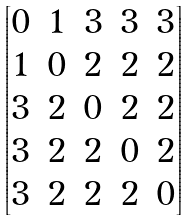<formula> <loc_0><loc_0><loc_500><loc_500>\begin{bmatrix} 0 & 1 & 3 & 3 & 3 \\ 1 & 0 & 2 & 2 & 2 \\ 3 & 2 & 0 & 2 & 2 \\ 3 & 2 & 2 & 0 & 2 \\ 3 & 2 & 2 & 2 & 0 \\ \end{bmatrix}</formula> 